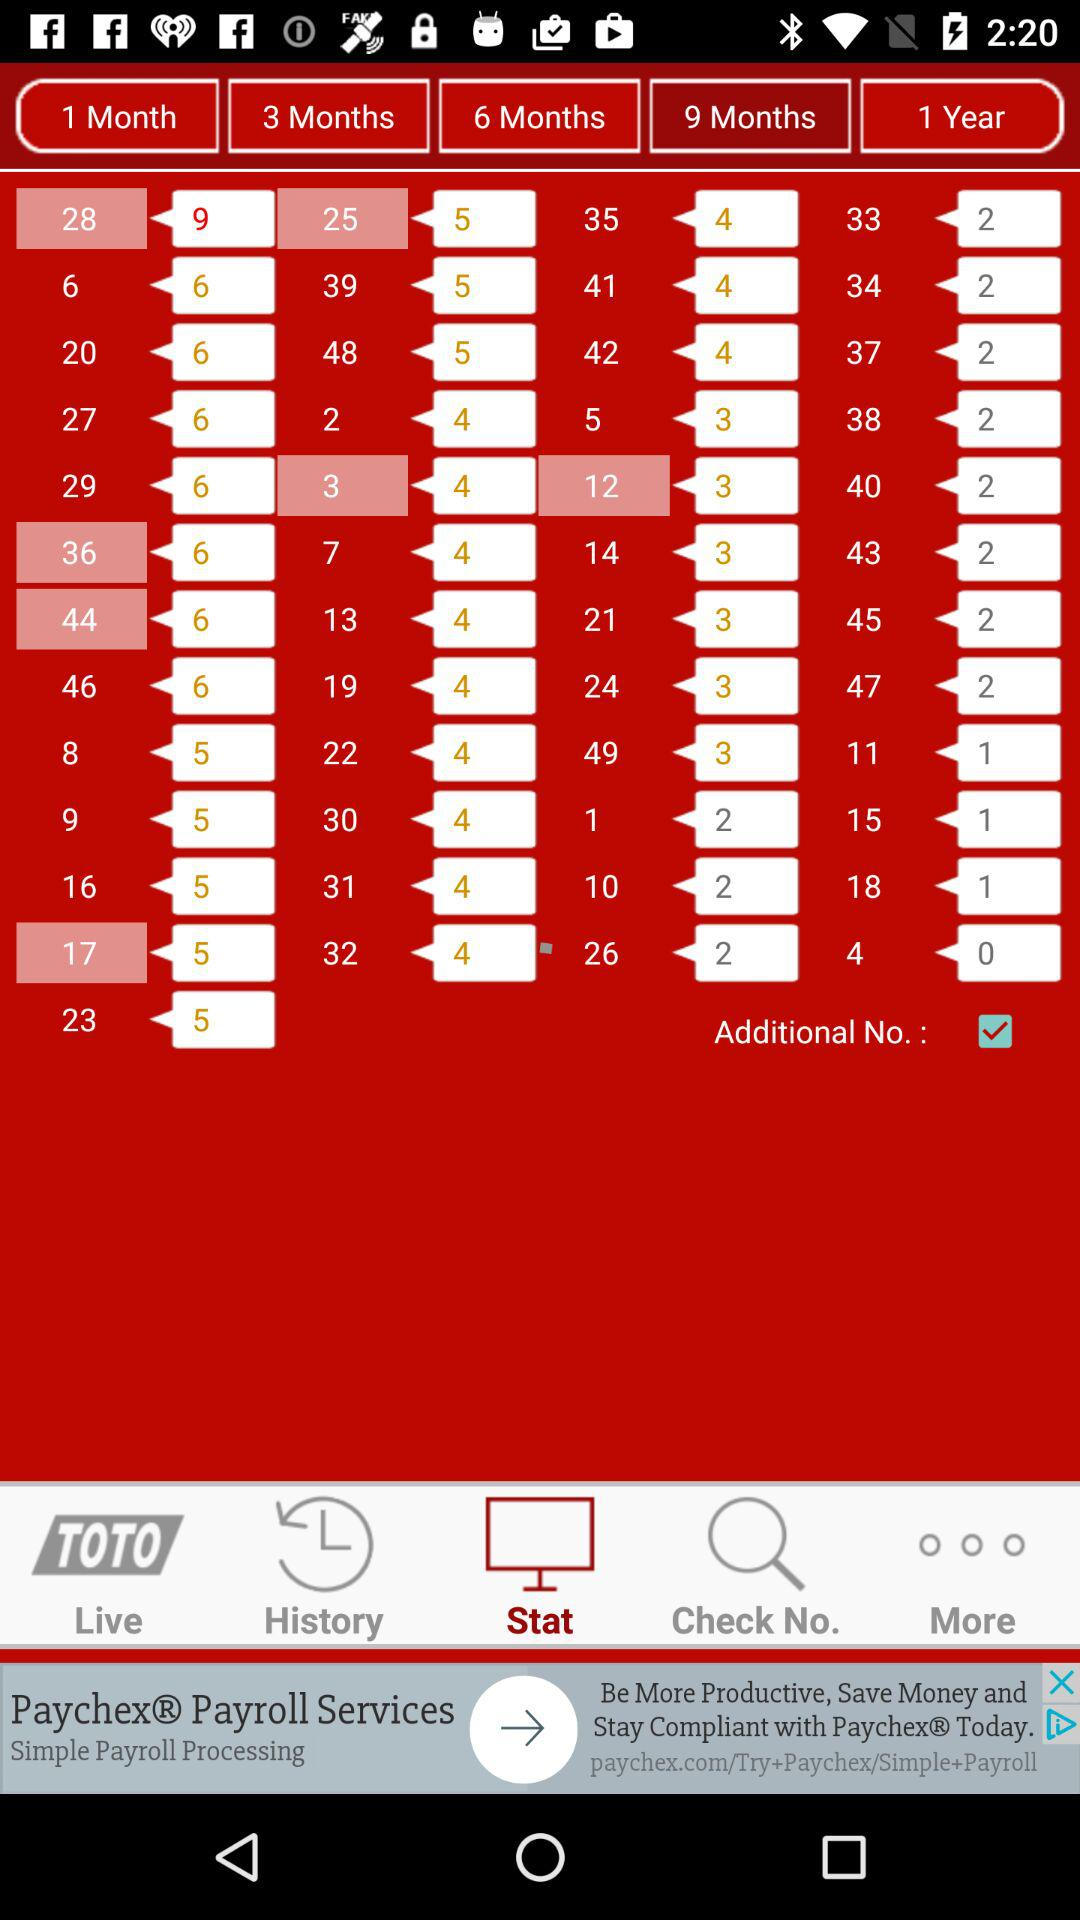How many more months of subscription do you get for the 1 year subscription than the 9 month subscription?
Answer the question using a single word or phrase. 3 